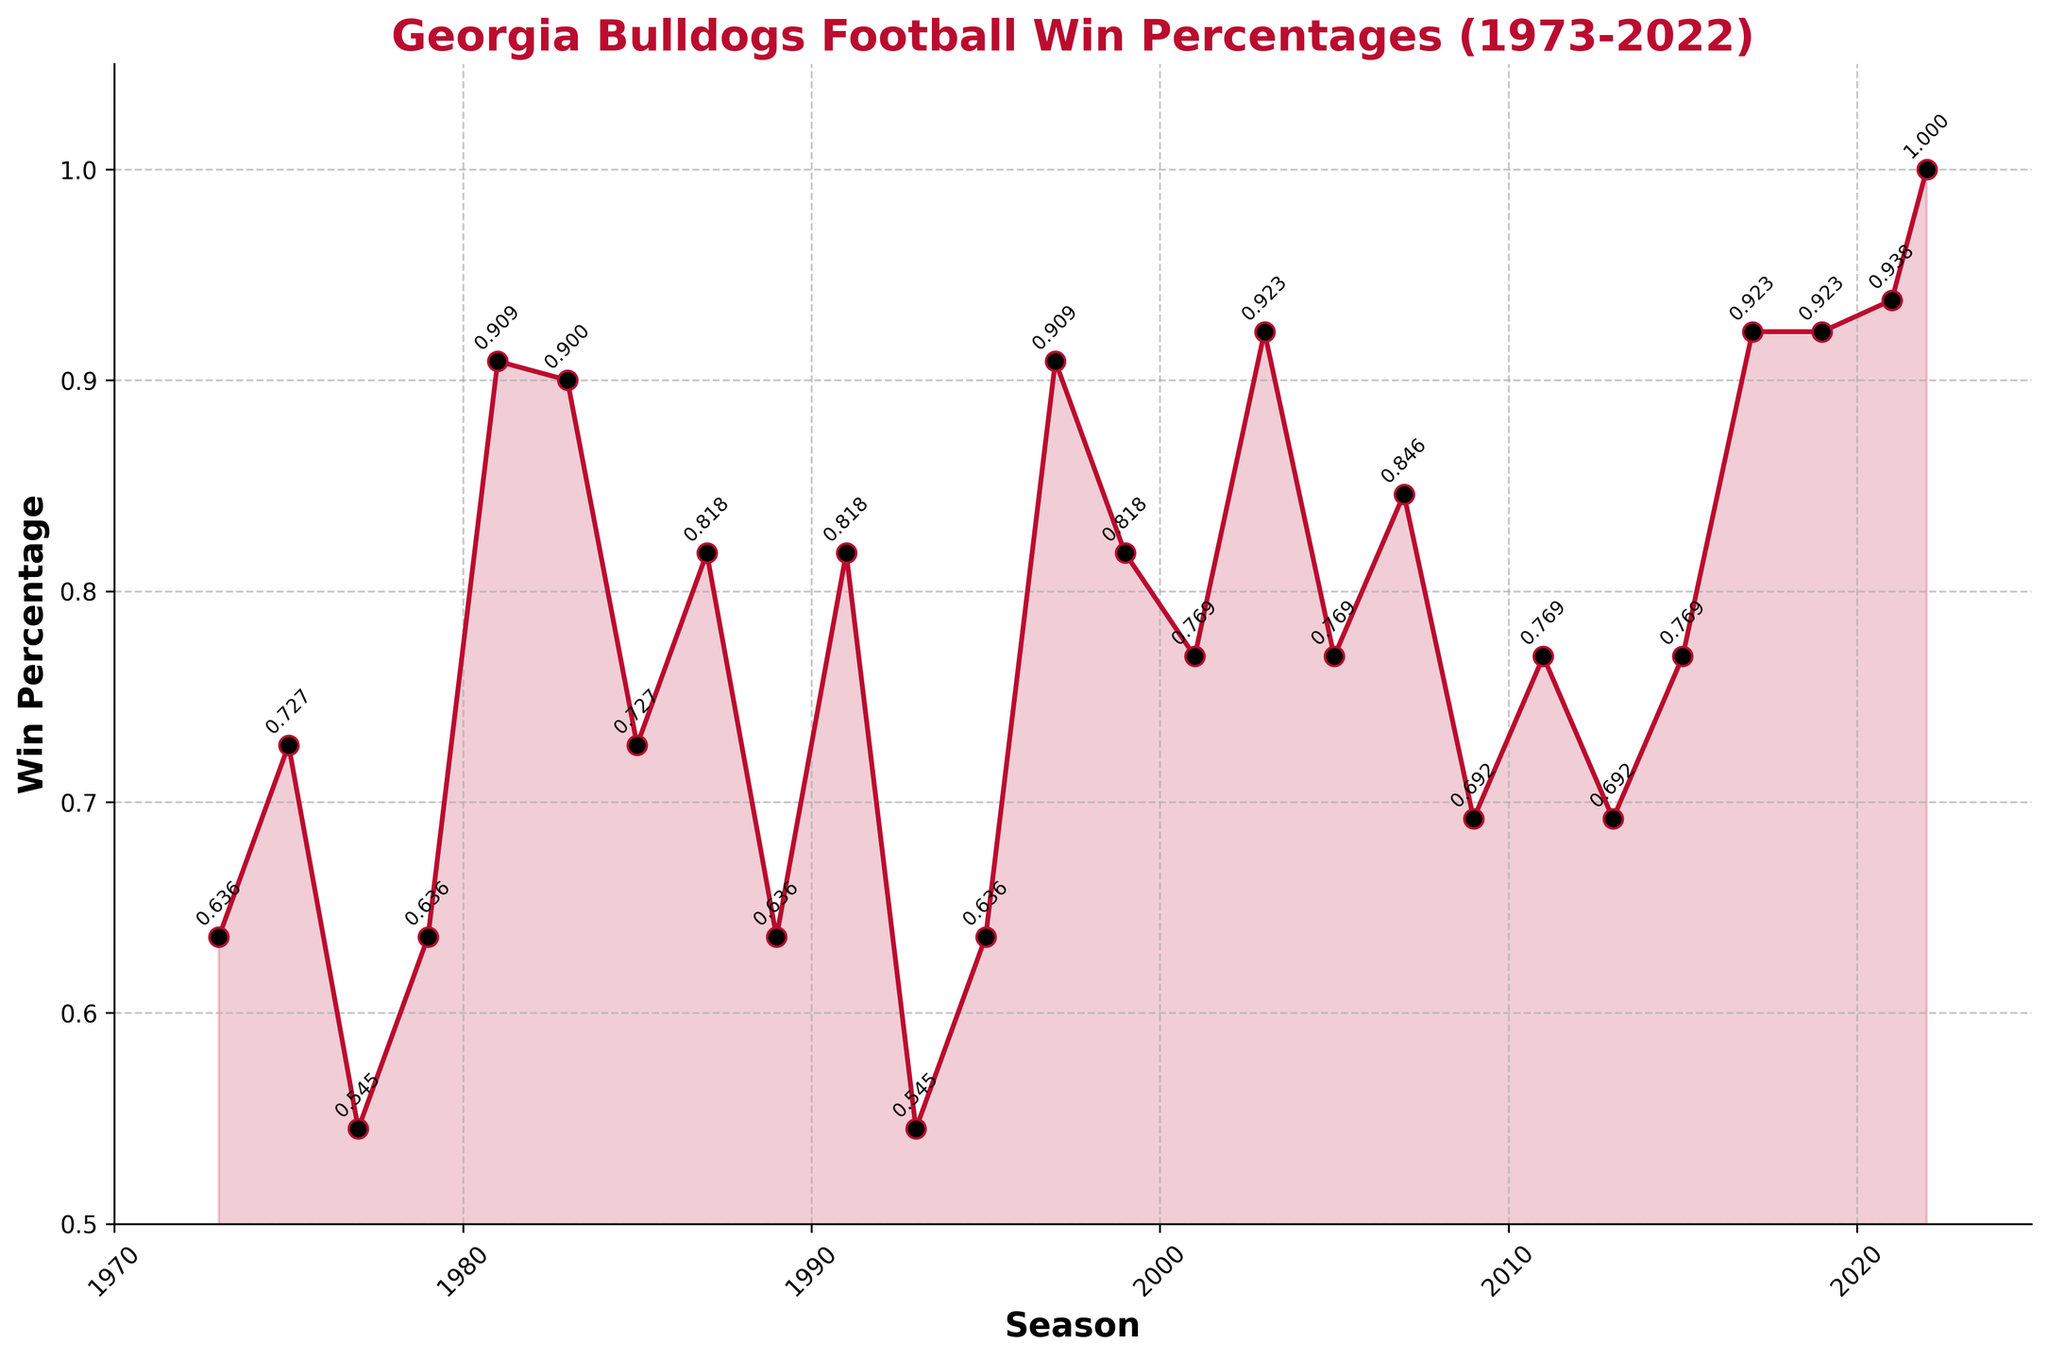What's the win percentage in the 2022 season? Referencing the last data point on the plot, the win percentage for the Georgia Bulldogs in 2022 is represented as 1.000.
Answer: 1.000 In which season(s) do the Bulldogs have a win percentage of 0.923? Looking at the annotated points, the win percentage of 0.923 occurs in the 2003, 2017, and 2019 seasons.
Answer: 2003, 2017, 2019 Which season shows the highest win percentage? By examining the plot, the highest win percentage is marked as 1.000 for the season 2022.
Answer: 2022 What is the difference in win percentage between 2001 and 2003? The win percentage in 2001 is 0.769, and in 2003, it is 0.923. The difference is 0.923 - 0.769.
Answer: 0.154 Which season experienced the lowest win percentage, and what was it? By inspecting the plot, the lowest win percentage is identified as 0.545 in both 1977 and 1993.
Answer: 1977, 1993 How many seasons had a win percentage of 0.769? From the plot, the annotated points with a win percentage of 0.769 are for seasons 2001, 2005, 2011, and 2015. Counting these, we get four seasons.
Answer: 4 During which periods did the win percentage remain consistently above 0.75 for at least three consecutive seasons? Observing the plot, from 2001 to 2005 and again from 2017 to 2022, the win percentage remained above 0.75.
Answer: 2001-2005, 2017-2022 What is the average win percentage for the last five seasons shown? The last five seasons are 2017 (0.923), 2019 (0.923), 2021 (0.938), and 2022 (1.000). The average is calculated as (0.923 + 0.923 + 0.938 + 1.000) / 4.
Answer: 0.946 